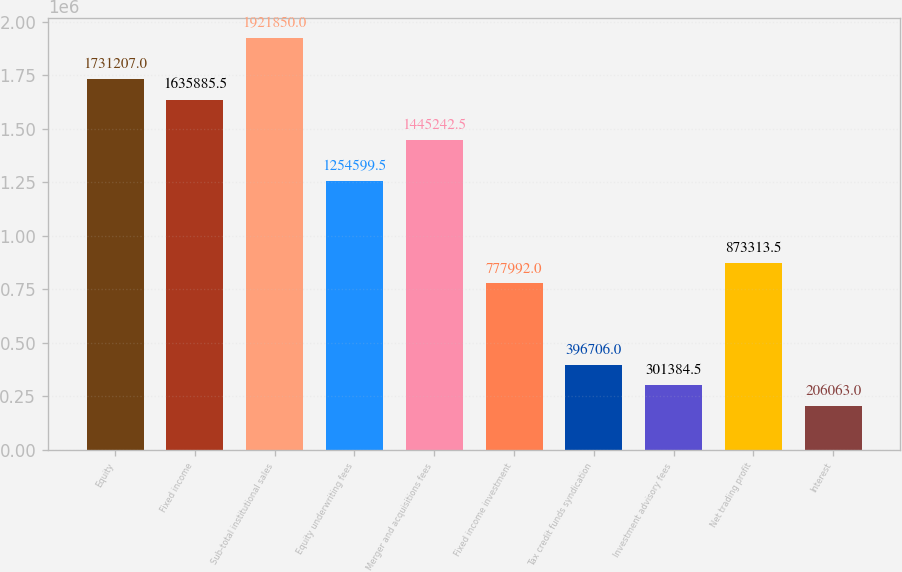Convert chart to OTSL. <chart><loc_0><loc_0><loc_500><loc_500><bar_chart><fcel>Equity<fcel>Fixed income<fcel>Sub-total institutional sales<fcel>Equity underwriting fees<fcel>Merger and acquisitions fees<fcel>Fixed income investment<fcel>Tax credit funds syndication<fcel>Investment advisory fees<fcel>Net trading profit<fcel>Interest<nl><fcel>1.73121e+06<fcel>1.63589e+06<fcel>1.92185e+06<fcel>1.2546e+06<fcel>1.44524e+06<fcel>777992<fcel>396706<fcel>301384<fcel>873314<fcel>206063<nl></chart> 